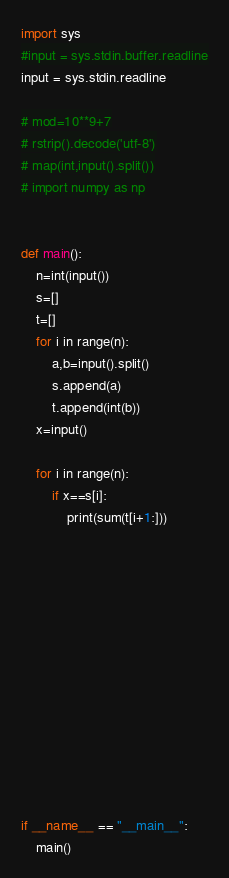<code> <loc_0><loc_0><loc_500><loc_500><_Python_>import sys
#input = sys.stdin.buffer.readline
input = sys.stdin.readline

# mod=10**9+7
# rstrip().decode('utf-8')
# map(int,input().split())
# import numpy as np


def main():
	n=int(input())
	s=[]
	t=[]
	for i in range(n):
		a,b=input().split()
		s.append(a)
		t.append(int(b))
	x=input()

	for i in range(n):
		if x==s[i]:
			print(sum(t[i+1:]))













if __name__ == "__main__":
	main()
</code> 